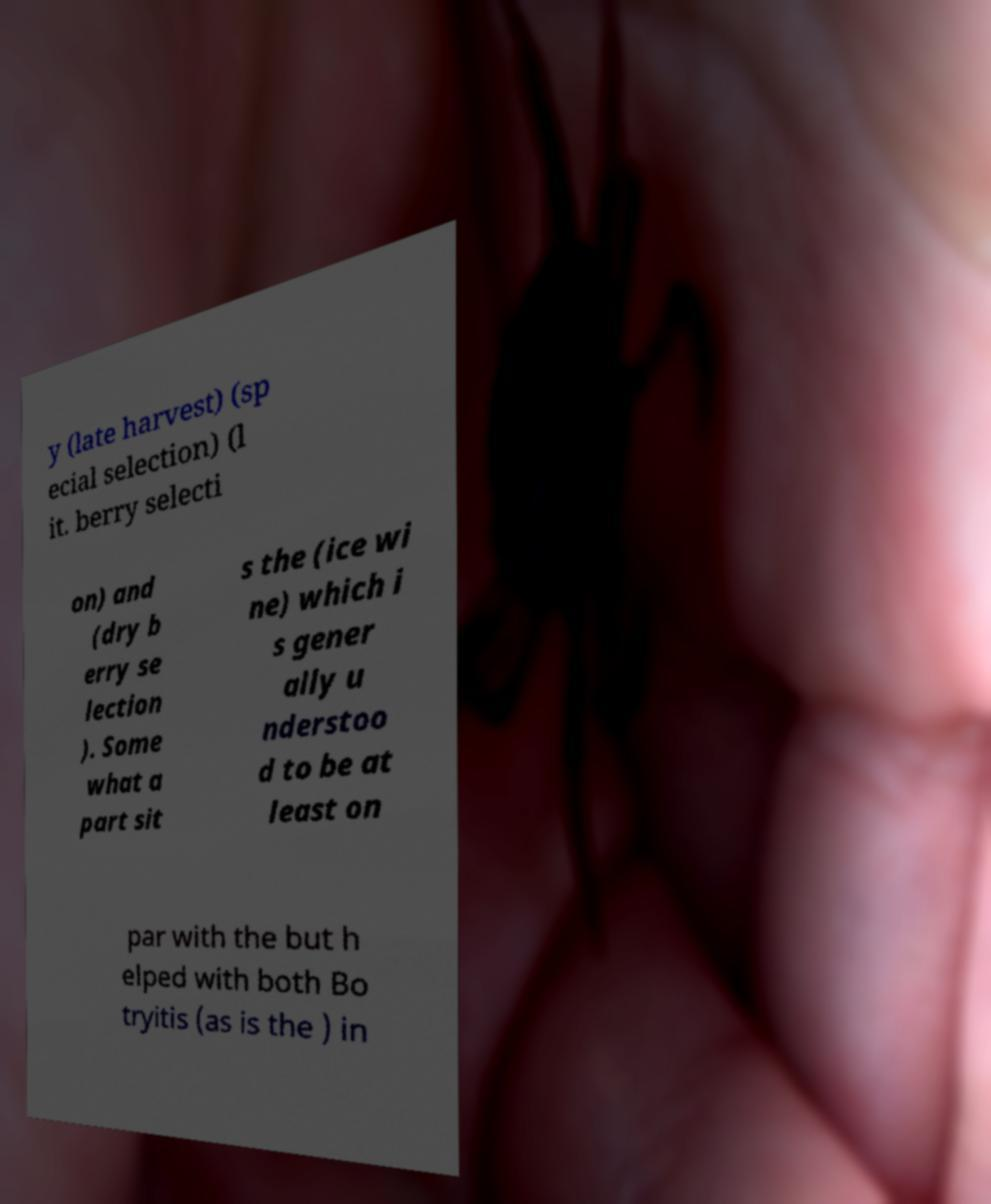Please read and relay the text visible in this image. What does it say? y (late harvest) (sp ecial selection) (l it. berry selecti on) and (dry b erry se lection ). Some what a part sit s the (ice wi ne) which i s gener ally u nderstoo d to be at least on par with the but h elped with both Bo tryitis (as is the ) in 